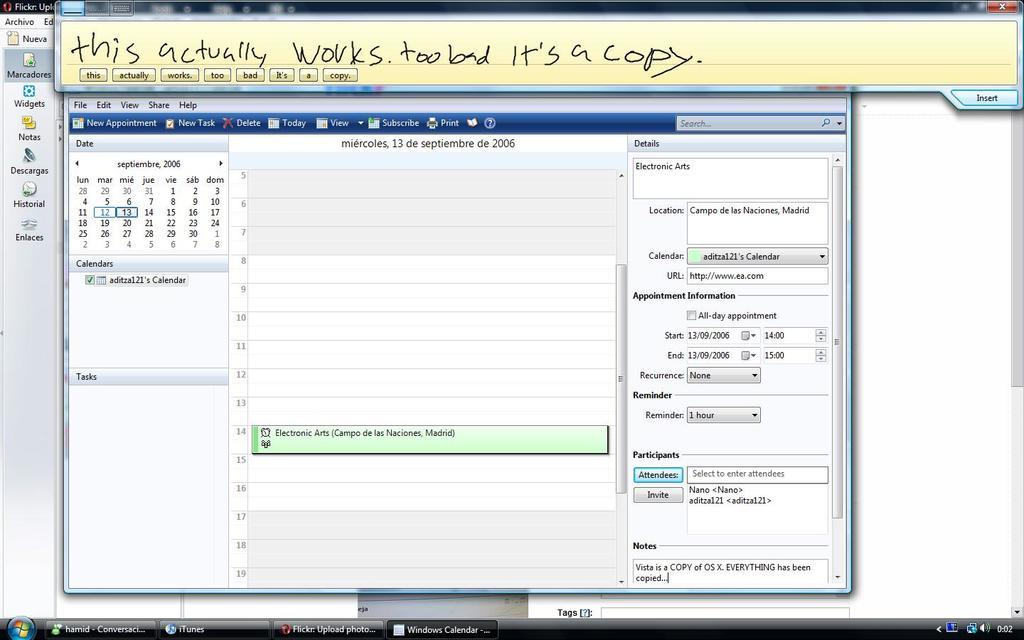Provide a one-sentence caption for the provided image. The writing at the top of the calendar page says that this actually works. 